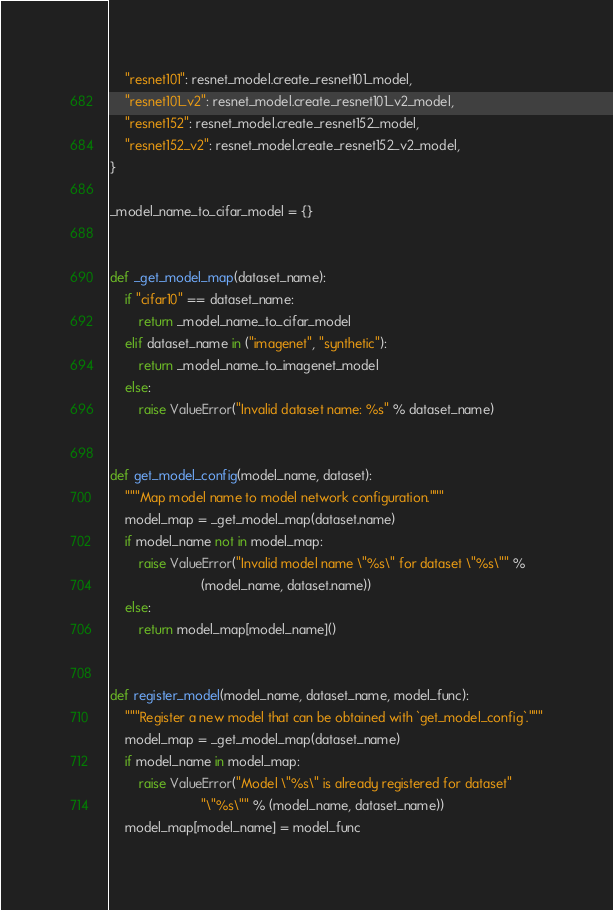Convert code to text. <code><loc_0><loc_0><loc_500><loc_500><_Python_>    "resnet101": resnet_model.create_resnet101_model,
    "resnet101_v2": resnet_model.create_resnet101_v2_model,
    "resnet152": resnet_model.create_resnet152_model,
    "resnet152_v2": resnet_model.create_resnet152_v2_model,
}

_model_name_to_cifar_model = {}


def _get_model_map(dataset_name):
    if "cifar10" == dataset_name:
        return _model_name_to_cifar_model
    elif dataset_name in ("imagenet", "synthetic"):
        return _model_name_to_imagenet_model
    else:
        raise ValueError("Invalid dataset name: %s" % dataset_name)


def get_model_config(model_name, dataset):
    """Map model name to model network configuration."""
    model_map = _get_model_map(dataset.name)
    if model_name not in model_map:
        raise ValueError("Invalid model name \"%s\" for dataset \"%s\"" %
                         (model_name, dataset.name))
    else:
        return model_map[model_name]()


def register_model(model_name, dataset_name, model_func):
    """Register a new model that can be obtained with `get_model_config`."""
    model_map = _get_model_map(dataset_name)
    if model_name in model_map:
        raise ValueError("Model \"%s\" is already registered for dataset"
                         "\"%s\"" % (model_name, dataset_name))
    model_map[model_name] = model_func
</code> 